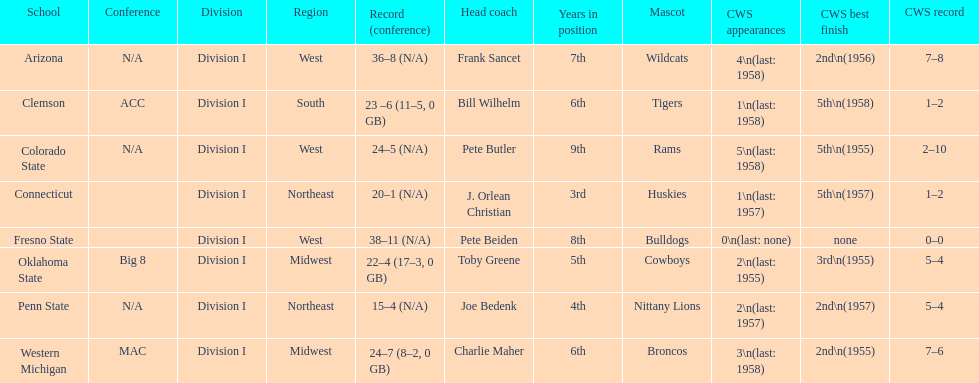Which team did not have more than 16 wins? Penn State. Give me the full table as a dictionary. {'header': ['School', 'Conference', 'Division', 'Region', 'Record (conference)', 'Head coach', 'Years in position', 'Mascot', 'CWS appearances', 'CWS best finish', 'CWS record'], 'rows': [['Arizona', 'N/A', 'Division I', 'West', '36–8 (N/A)', 'Frank Sancet', '7th', 'Wildcats', '4\\n(last: 1958)', '2nd\\n(1956)', '7–8'], ['Clemson', 'ACC', 'Division I', 'South', '23 –6 (11–5, 0 GB)', 'Bill Wilhelm', '6th', 'Tigers', '1\\n(last: 1958)', '5th\\n(1958)', '1–2'], ['Colorado State', 'N/A', 'Division I', 'West', '24–5 (N/A)', 'Pete Butler', '9th', 'Rams', '5\\n(last: 1958)', '5th\\n(1955)', '2–10'], ['Connecticut', '', 'Division I', 'Northeast', '20–1 (N/A)', 'J. Orlean Christian', '3rd', 'Huskies', '1\\n(last: 1957)', '5th\\n(1957)', '1–2'], ['Fresno State', '', 'Division I', 'West', '38–11 (N/A)', 'Pete Beiden', '8th', 'Bulldogs', '0\\n(last: none)', 'none', '0–0'], ['Oklahoma State', 'Big 8', 'Division I', 'Midwest', '22–4 (17–3, 0 GB)', 'Toby Greene', '5th', 'Cowboys', '2\\n(last: 1955)', '3rd\\n(1955)', '5–4'], ['Penn State', 'N/A', 'Division I', 'Northeast', '15–4 (N/A)', 'Joe Bedenk', '4th', 'Nittany Lions', '2\\n(last: 1957)', '2nd\\n(1957)', '5–4'], ['Western Michigan', 'MAC', 'Division I', 'Midwest', '24–7 (8–2, 0 GB)', 'Charlie Maher', '6th', 'Broncos', '3\\n(last: 1958)', '2nd\\n(1955)', '7–6']]} 